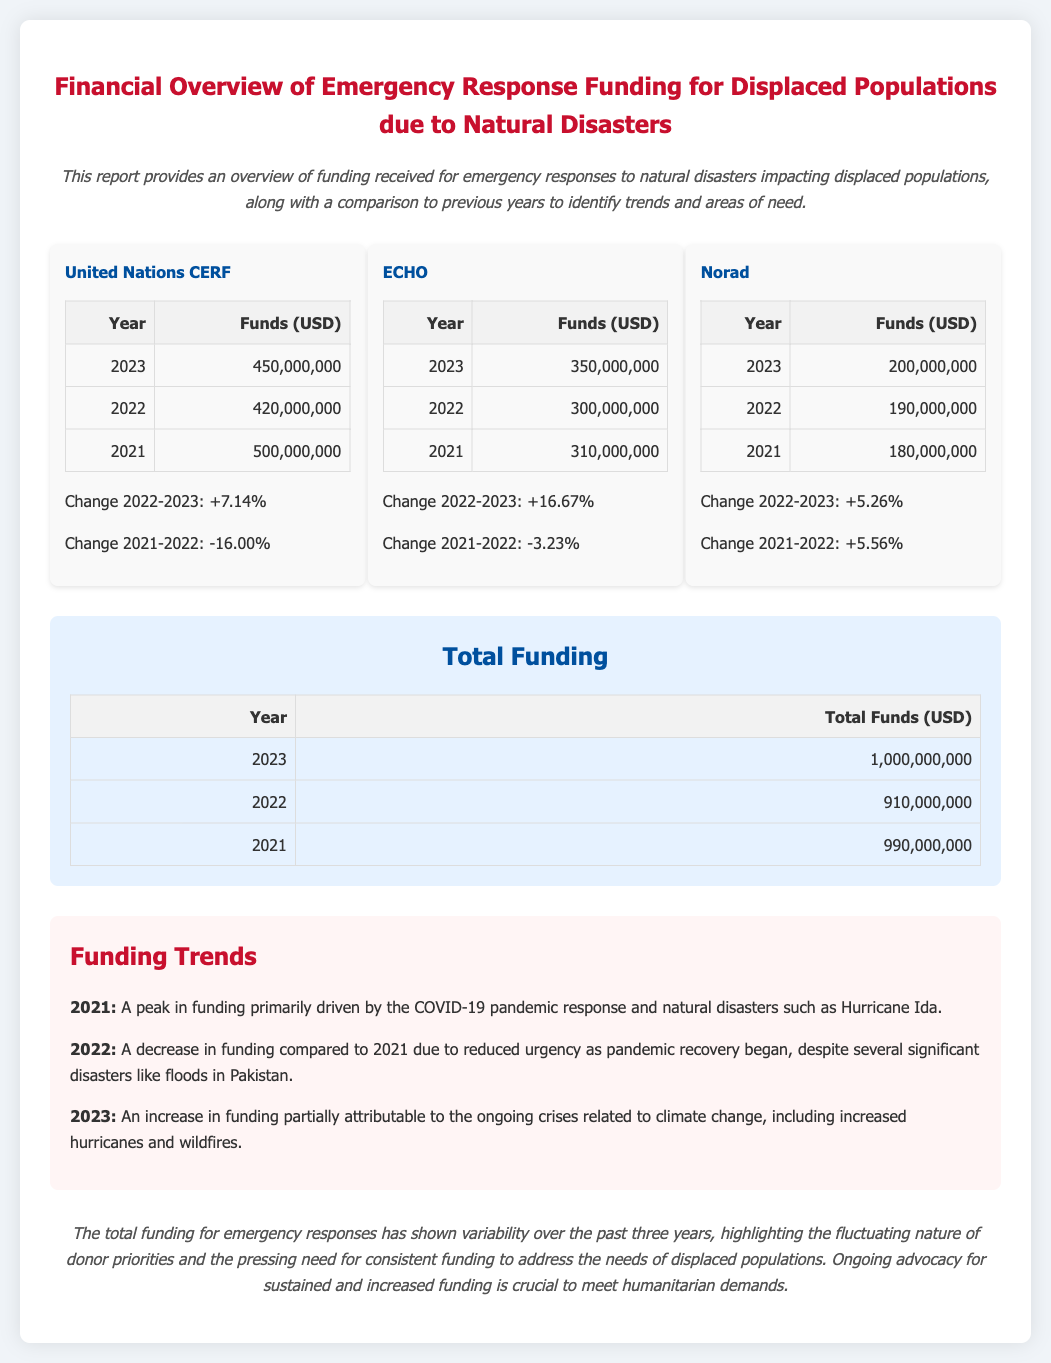what is the total funding for 2023? The total funding is clearly listed for each year, where 2023 shows total funds of 1,000,000,000 USD.
Answer: 1,000,000,000 what was the funding from United Nations CERF in 2022? The funding amounts for United Nations CERF are detailed in the table, showing 2022 funds of 420,000,000 USD.
Answer: 420,000,000 which organization saw a decrease in funding from 2021 to 2022? The data presented for each organization includes changes over the years, revealing that United Nations CERF had a decrease in funds from 2021 to 2022, at -16.00%.
Answer: United Nations CERF how much did ECHO receive in 2023? The funds for ECHO are documented, with 2023 funding amounting to 350,000,000 USD.
Answer: 350,000,000 what trend was observed in 2021 for emergency response funding? The document describes funding trends, indicating that 2021 was a peak year primarily driven by the COVID-19 pandemic response and other natural disasters.
Answer: Peak year due to COVID-19 what was the percentage increase for Norad funding from 2022 to 2023? The document includes change percentages, showing that Norad funding increased by 5.26% from 2022 to 2023.
Answer: 5.26% what did the total funding decrease to in 2022 compared to 2021? The document provides a direct comparison, indicating that total funding fell from 990,000,000 USD in 2021 to 910,000,000 USD in 2022.
Answer: 910,000,000 what is highlighted as a crucial need by the report's conclusion? The conclusion emphasizes ongoing advocacy for sustained funding as an essential need for humanitarian demands.
Answer: Sustained funding how much funding did Norad receive in 2021? The report includes specific annual funding figures, showing that Norad received 180,000,000 USD in 2021.
Answer: 180,000,000 